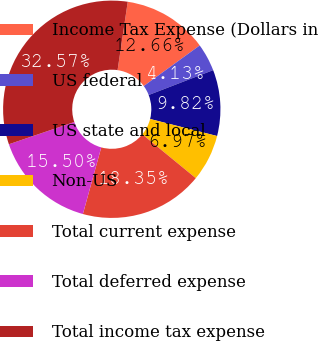<chart> <loc_0><loc_0><loc_500><loc_500><pie_chart><fcel>Income Tax Expense (Dollars in<fcel>US federal<fcel>US state and local<fcel>Non-US<fcel>Total current expense<fcel>Total deferred expense<fcel>Total income tax expense<nl><fcel>12.66%<fcel>4.13%<fcel>9.82%<fcel>6.97%<fcel>18.35%<fcel>15.5%<fcel>32.57%<nl></chart> 